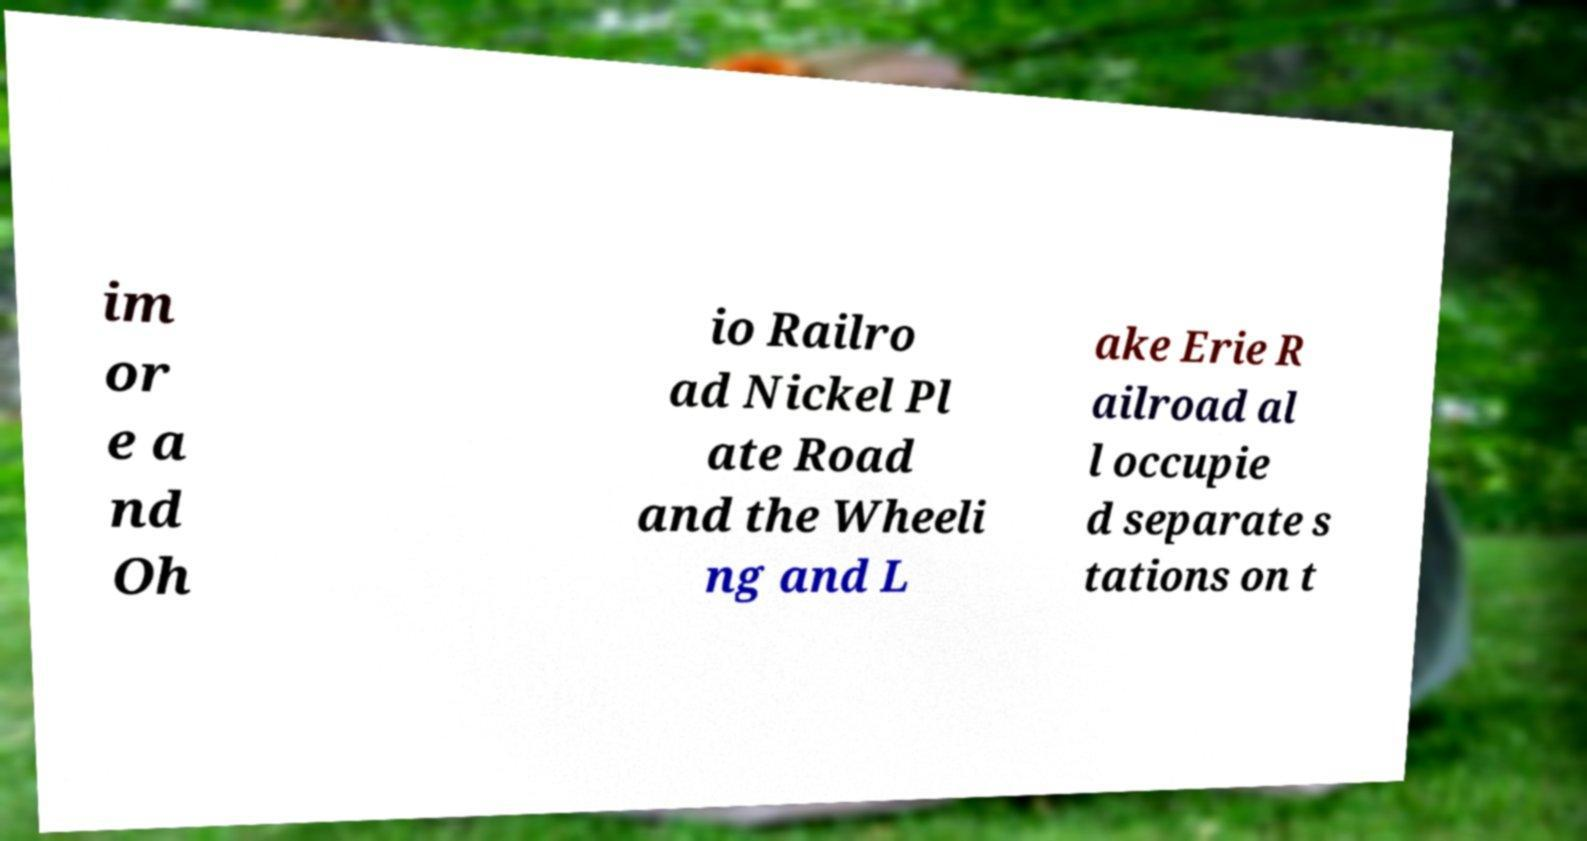There's text embedded in this image that I need extracted. Can you transcribe it verbatim? im or e a nd Oh io Railro ad Nickel Pl ate Road and the Wheeli ng and L ake Erie R ailroad al l occupie d separate s tations on t 